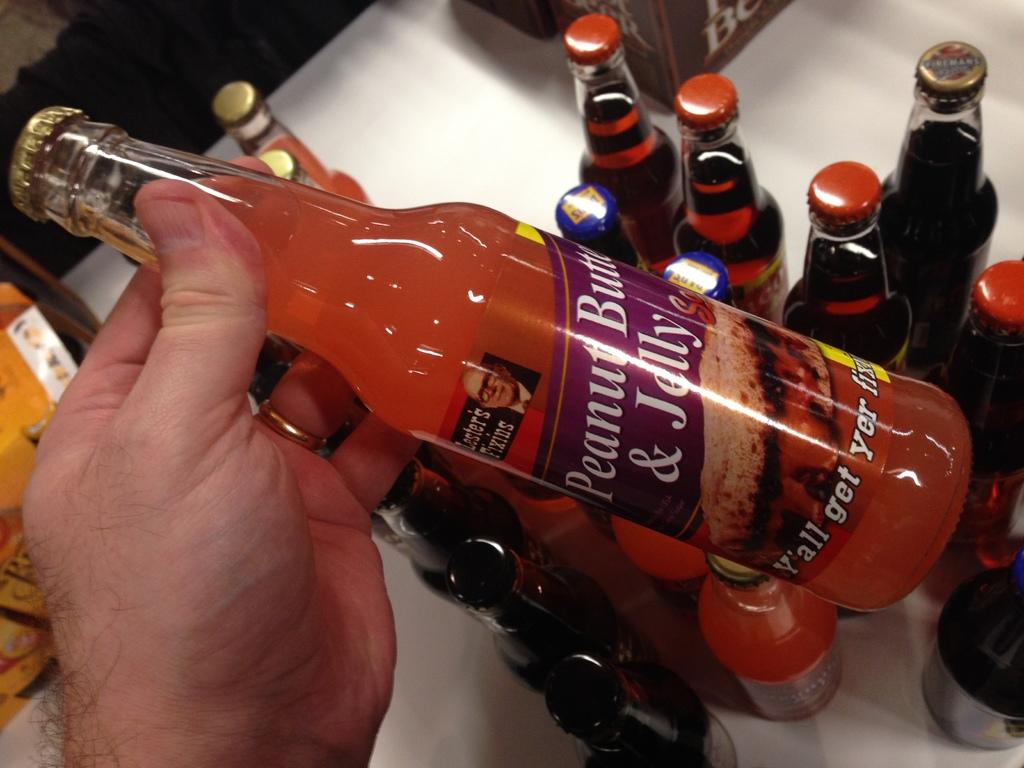<image>
Relay a brief, clear account of the picture shown. A hand holding a bottle of Peanut Butter and Jelly. 